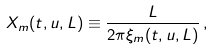<formula> <loc_0><loc_0><loc_500><loc_500>X _ { m } ( t , u , L ) \equiv \frac { L } { 2 \pi \xi _ { m } ( t , u , L ) } \, ,</formula> 